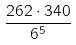Convert formula to latex. <formula><loc_0><loc_0><loc_500><loc_500>\frac { 2 6 2 \cdot 3 4 0 } { 6 ^ { 5 } }</formula> 